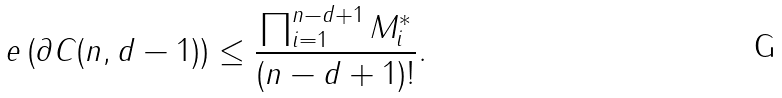Convert formula to latex. <formula><loc_0><loc_0><loc_500><loc_500>e \left ( \partial C ( n , d - 1 ) \right ) \leq \frac { \prod _ { i = 1 } ^ { n - d + 1 } M _ { i } ^ { * } } { ( n - d + 1 ) ! } .</formula> 